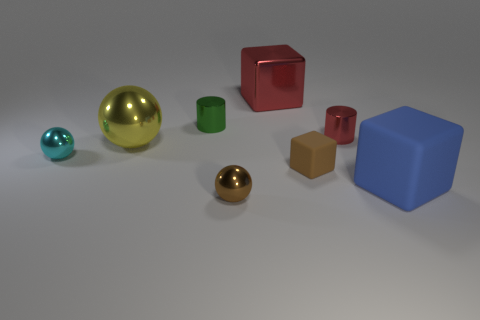Add 1 small blue matte spheres. How many objects exist? 9 Subtract all cubes. How many objects are left? 5 Add 2 red objects. How many red objects are left? 4 Add 8 large red blocks. How many large red blocks exist? 9 Subtract 0 cyan cylinders. How many objects are left? 8 Subtract all small brown balls. Subtract all blue cubes. How many objects are left? 6 